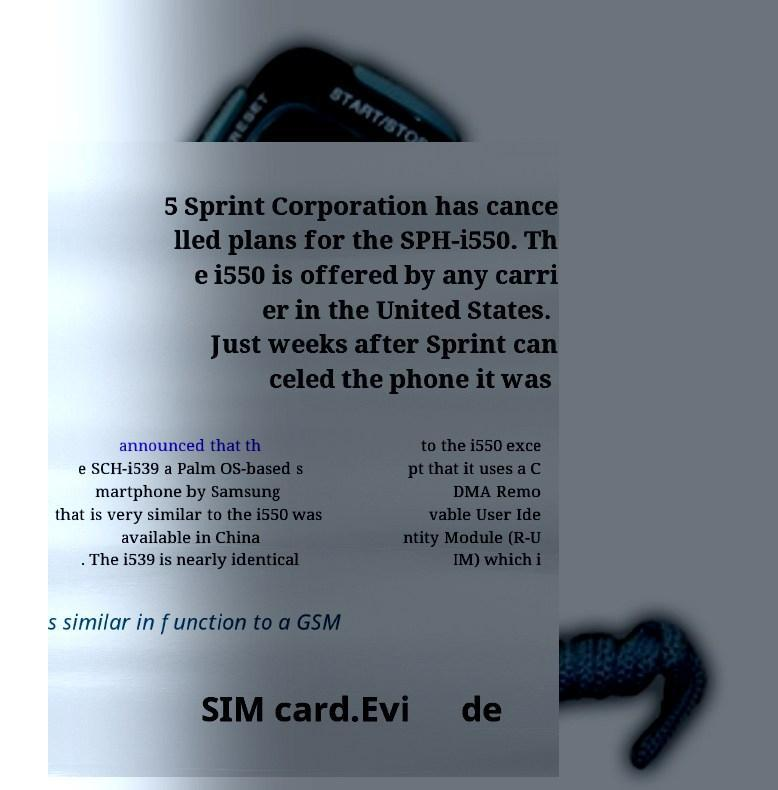I need the written content from this picture converted into text. Can you do that? 5 Sprint Corporation has cance lled plans for the SPH-i550. Th e i550 is offered by any carri er in the United States. Just weeks after Sprint can celed the phone it was announced that th e SCH-i539 a Palm OS-based s martphone by Samsung that is very similar to the i550 was available in China . The i539 is nearly identical to the i550 exce pt that it uses a C DMA Remo vable User Ide ntity Module (R-U IM) which i s similar in function to a GSM SIM card.Evi de 